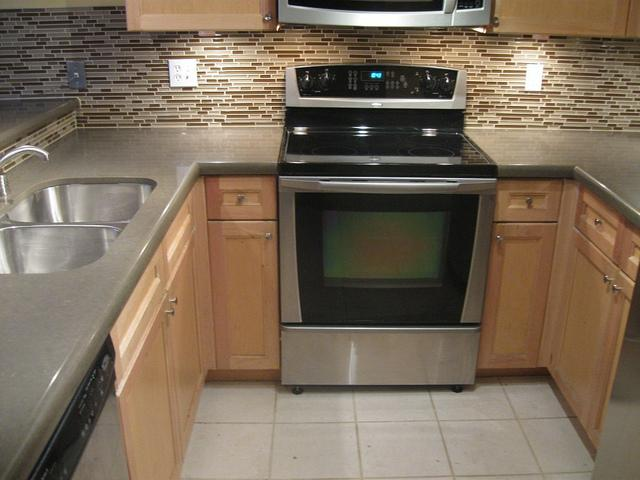What is the innermost color reflected off the center of the oven? red 